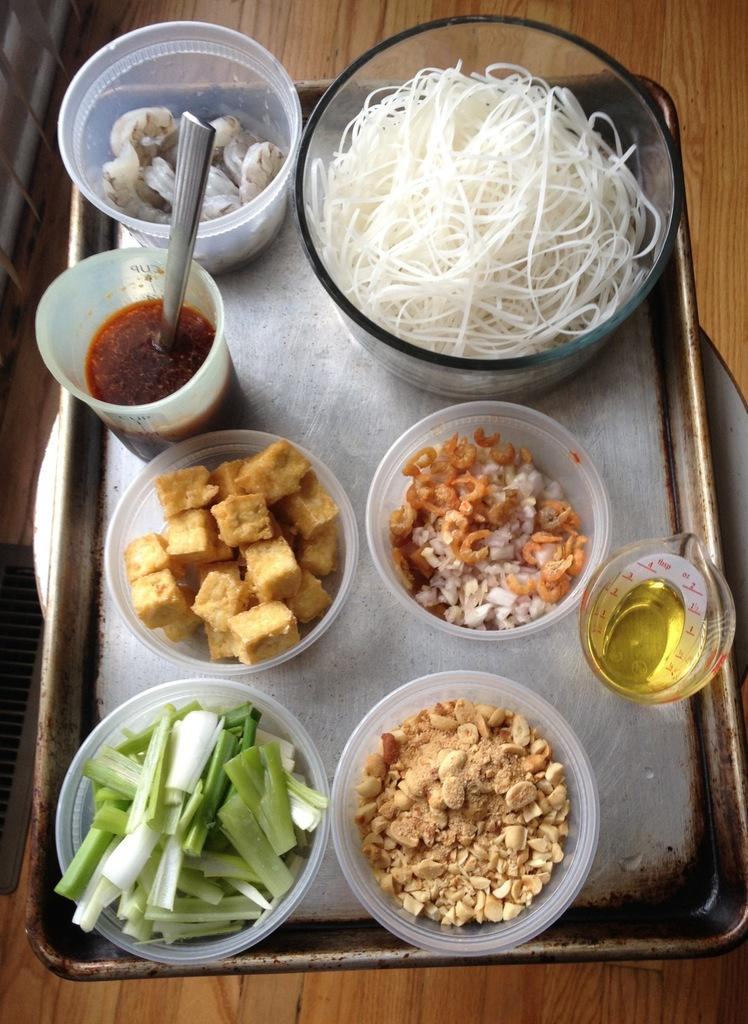What is present on the plate in the image? There is a plate in the image, and it contains multiple bowls. What might be the purpose of the bowls on the plate? The bowls appear to contain ingredients for a noodle recipe. How many nuts are visible in the image? There are no nuts visible in the image. 